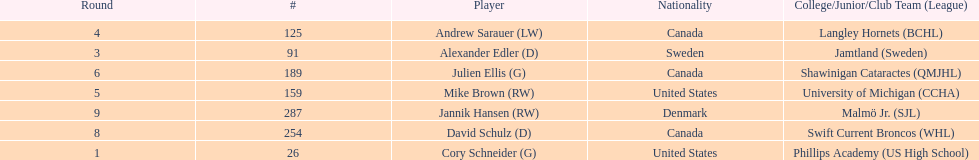The first round not to have a draft pick. 2. 